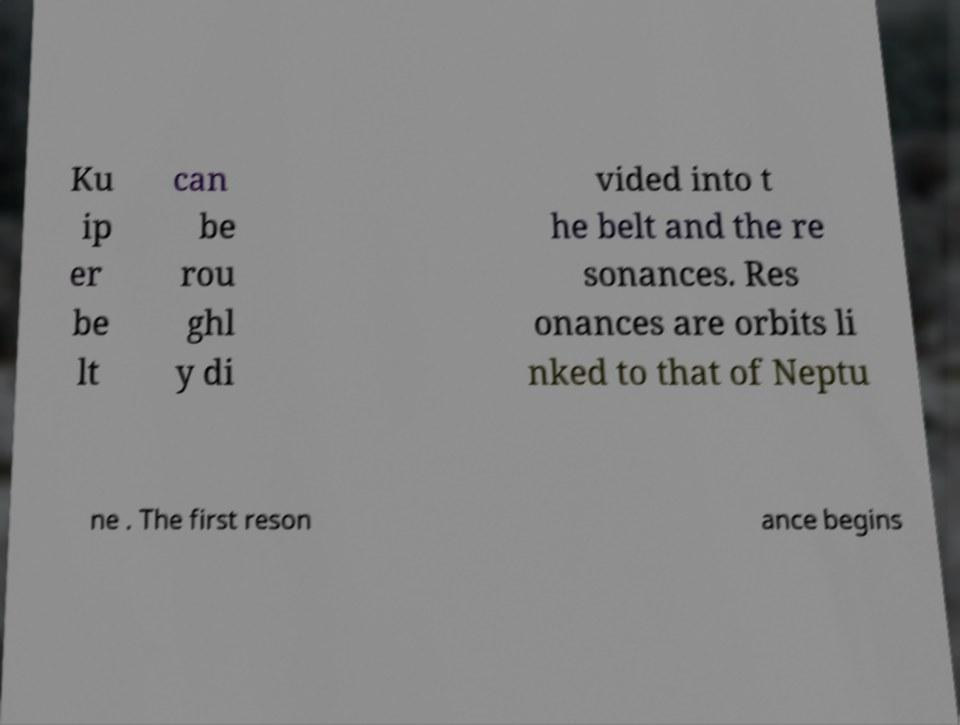I need the written content from this picture converted into text. Can you do that? Ku ip er be lt can be rou ghl y di vided into t he belt and the re sonances. Res onances are orbits li nked to that of Neptu ne . The first reson ance begins 